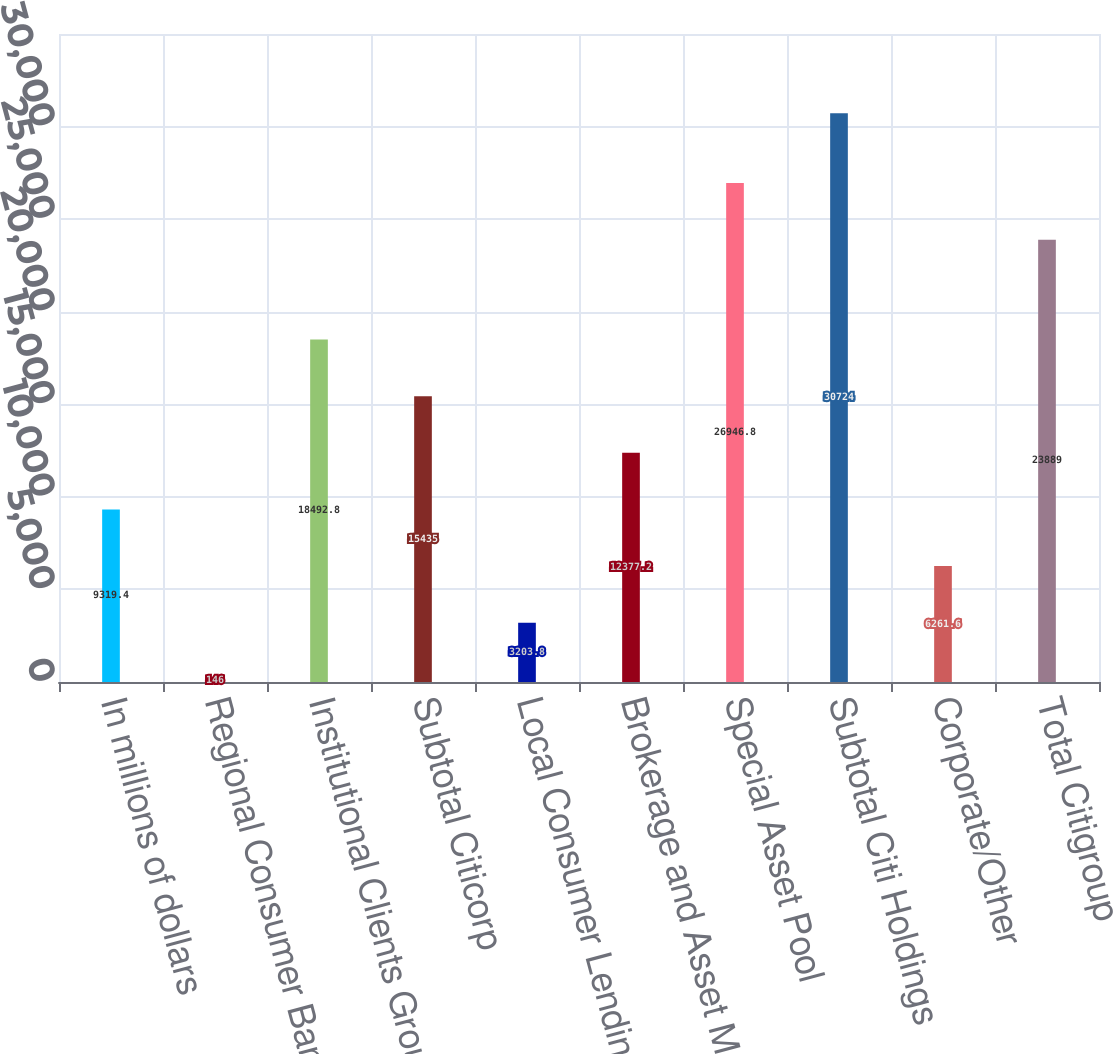Convert chart. <chart><loc_0><loc_0><loc_500><loc_500><bar_chart><fcel>In millions of dollars<fcel>Regional Consumer Banking<fcel>Institutional Clients Group<fcel>Subtotal Citicorp<fcel>Local Consumer Lending<fcel>Brokerage and Asset Management<fcel>Special Asset Pool<fcel>Subtotal Citi Holdings<fcel>Corporate/Other<fcel>Total Citigroup<nl><fcel>9319.4<fcel>146<fcel>18492.8<fcel>15435<fcel>3203.8<fcel>12377.2<fcel>26946.8<fcel>30724<fcel>6261.6<fcel>23889<nl></chart> 